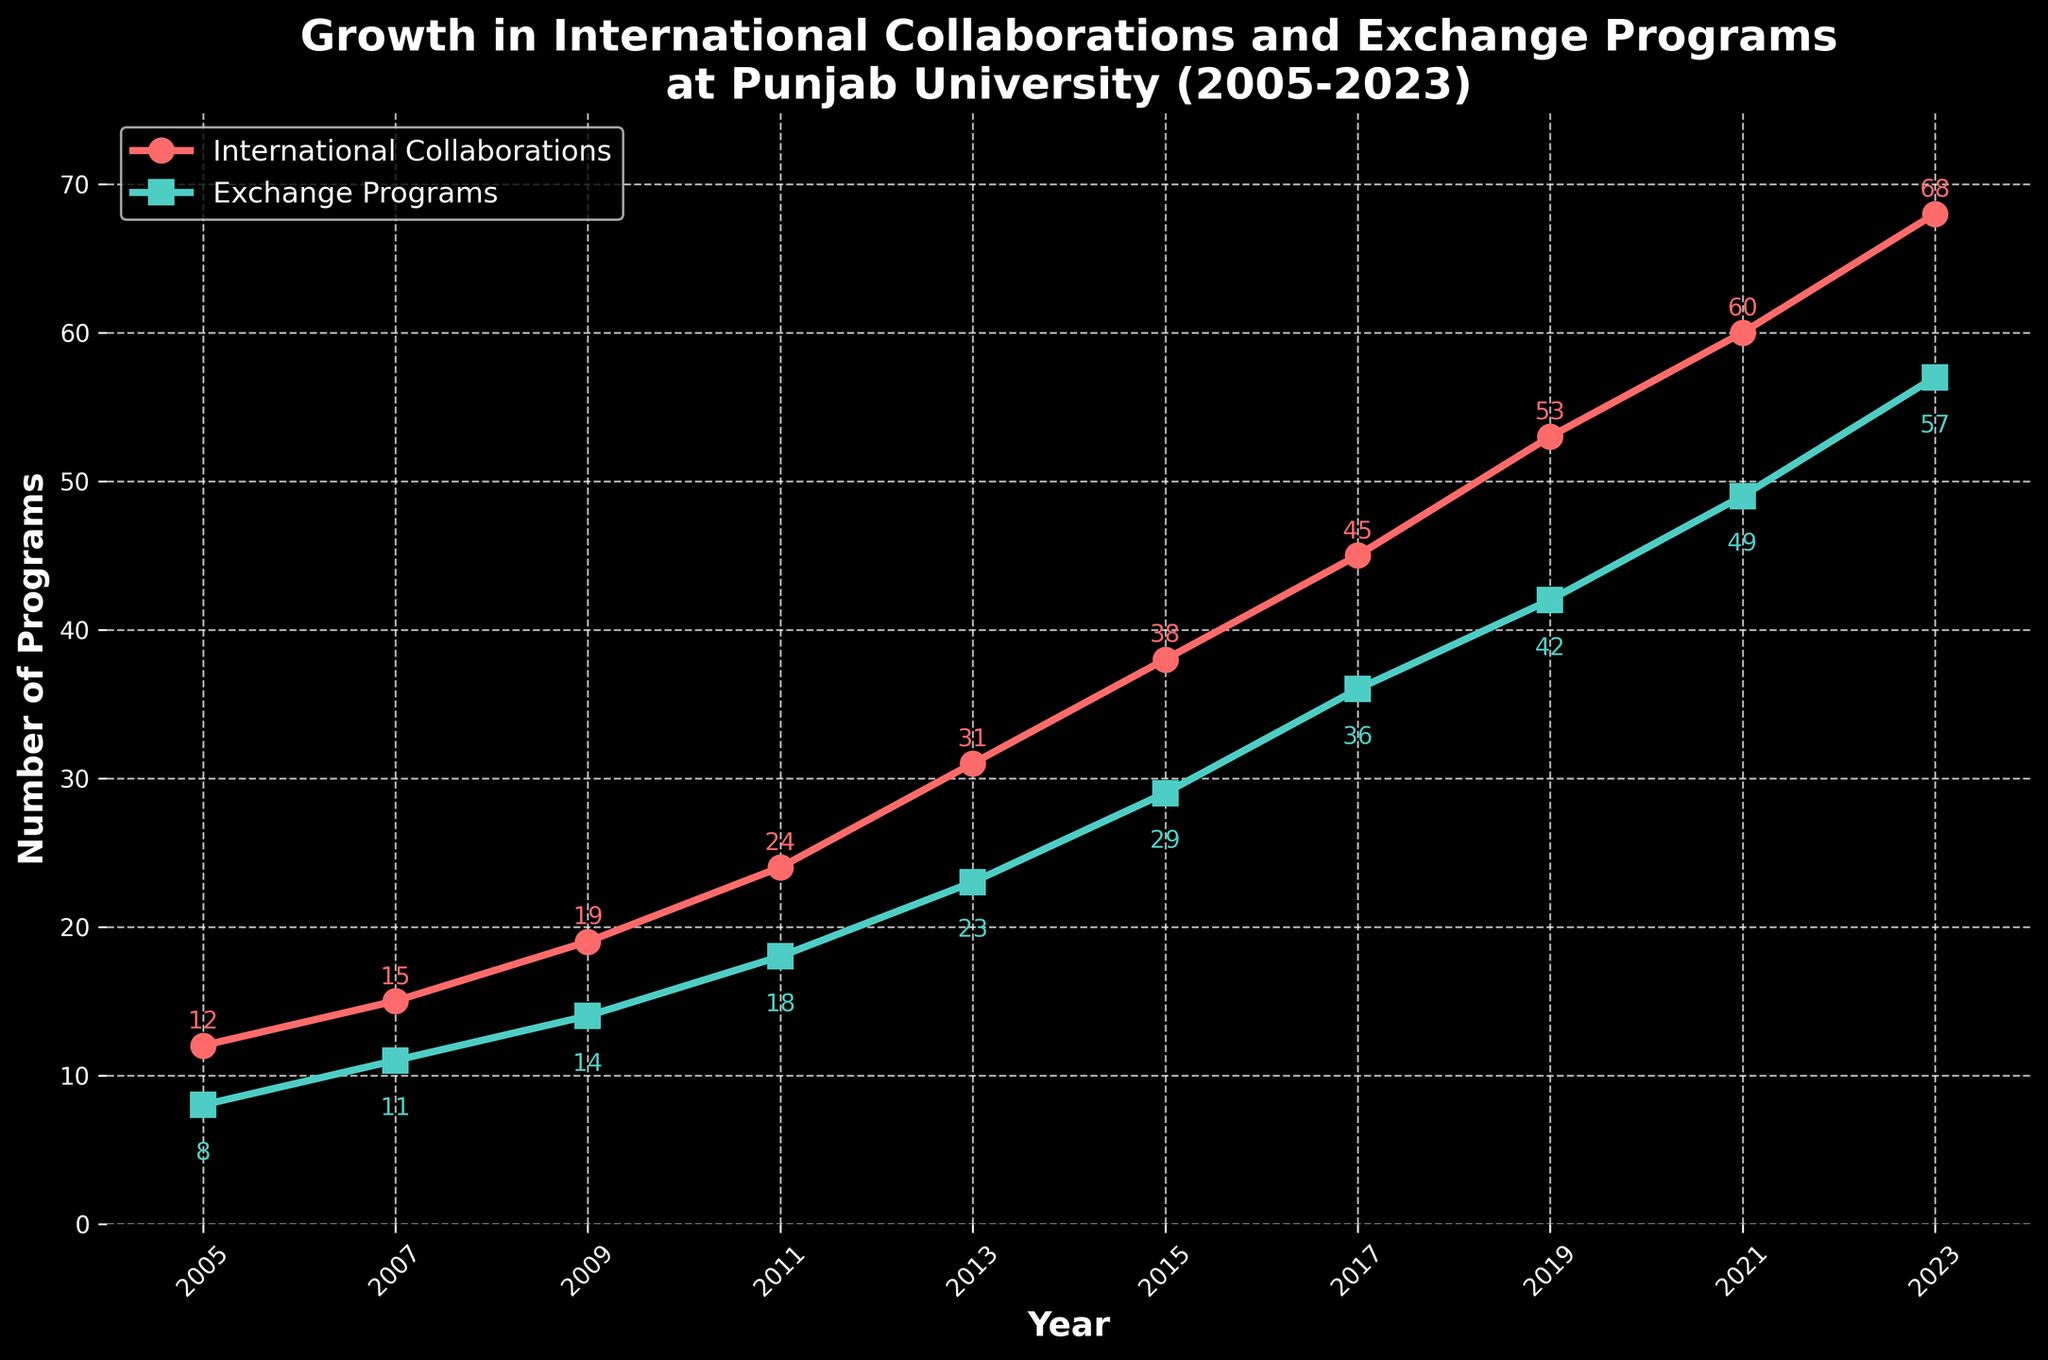What year saw the highest number of international collaborations? The year with the highest point on the red line representing international collaborations will show the maximum number.
Answer: 2023 Which year had more exchange programs, 2015 or 2017? Compare the position of the points on the green line for the years 2015 and 2017. See which is higher.
Answer: 2017 By how much did the number of international collaborations increase from 2005 to 2011? Find the difference between the points on the red line for 2005 and 2011. Subtract the value in 2005 from the value in 2011.
Answer: 12 What is the average number of exchange programs from 2005 to 2023? Sum all values of exchange programs and divide by the number of years. (8+11+14+18+23+29+36+42+49+57) / 10 = 287 / 10 = 28.7
Answer: 28.7 By how many did international collaborations and exchange programs differ in 2013? Find the difference between points on the red and green lines for the year 2013. Subtract the number of exchange programs from the number of collaborations.
Answer: 8 Which year showed equal numbers of international collaborations and exchange programs? Look for points where the red and green lines intersect.
Answer: None How much did the number of exchange programs grow from 2013 to 2021? Find the difference between the points on the green line for the years 2021 and 2013. Subtract the value in 2013 from the value in 2021.
Answer: 26 By what percentage did international collaborations increase from 2005 to 2023? Calculate the increase and then divide by the initial value in 2005, multiply by 100. ((68-12)/12) * 100 = 466.67%
Answer: 466.67% Which program showed a steeper increase between 2011 and 2015, international collaborations or exchange programs? Compare the slope between the points for the two lines, observing the visual steepness between these years.
Answer: International Collaborations What is the difference in the number of exchange programs between 2007 and 2019? Find the difference between points on the green line for 2019 and 2007. Subtract the value in 2007 from the value in 2019.
Answer: 31 